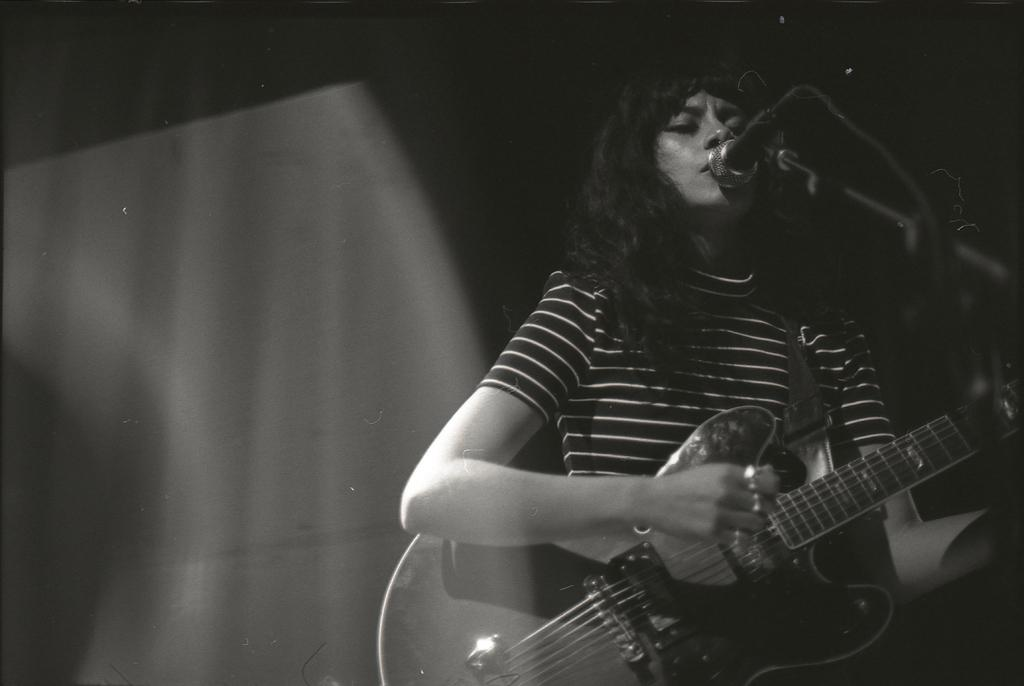What is the woman in the image doing? The woman is singing and playing a guitar. What is the woman holding in the image? The woman is holding a microphone. What can be observed about the background of the image? The background of the image is dark. How many giants are present in the image? There are no giants present in the image; it features a woman singing and playing a guitar. 